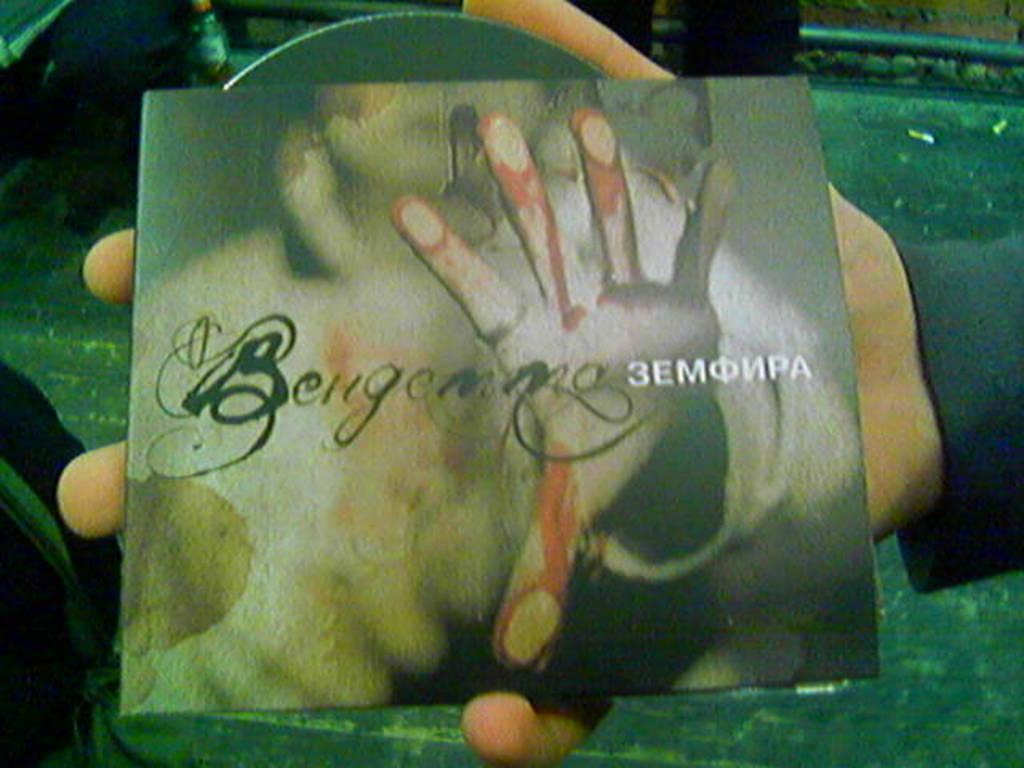What is the person's hand holding in the image? The person's hand is holding a CD cover in the image. What is located beneath the hand in the image? There is a table below the hand. What can be seen on the table in the image? There are objects on the table. What type of wall is visible at the top right of the image? There is a brick wall at the top right of the image. How many stars can be seen on the CD cover in the image? There are no stars visible on the CD cover in the image. What type of monkey is sitting on the table in the image? There is no monkey present in the image. 